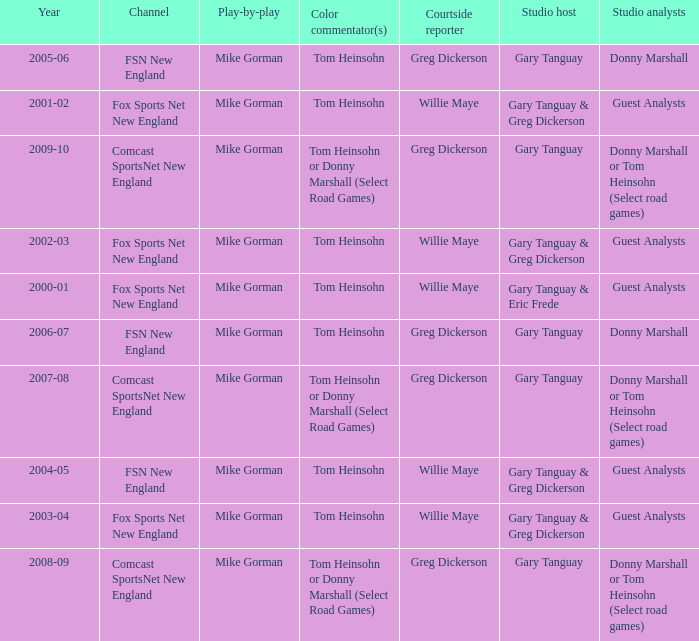WHich Studio analysts has a Studio host of gary tanguay in 2009-10? Donny Marshall or Tom Heinsohn (Select road games). 